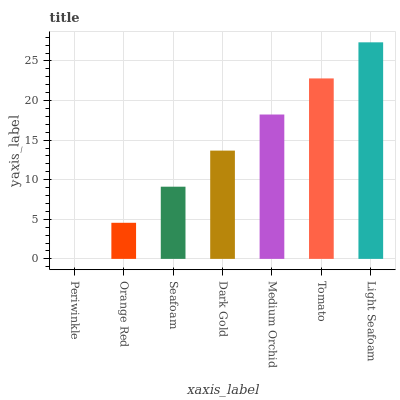Is Periwinkle the minimum?
Answer yes or no. Yes. Is Light Seafoam the maximum?
Answer yes or no. Yes. Is Orange Red the minimum?
Answer yes or no. No. Is Orange Red the maximum?
Answer yes or no. No. Is Orange Red greater than Periwinkle?
Answer yes or no. Yes. Is Periwinkle less than Orange Red?
Answer yes or no. Yes. Is Periwinkle greater than Orange Red?
Answer yes or no. No. Is Orange Red less than Periwinkle?
Answer yes or no. No. Is Dark Gold the high median?
Answer yes or no. Yes. Is Dark Gold the low median?
Answer yes or no. Yes. Is Tomato the high median?
Answer yes or no. No. Is Seafoam the low median?
Answer yes or no. No. 